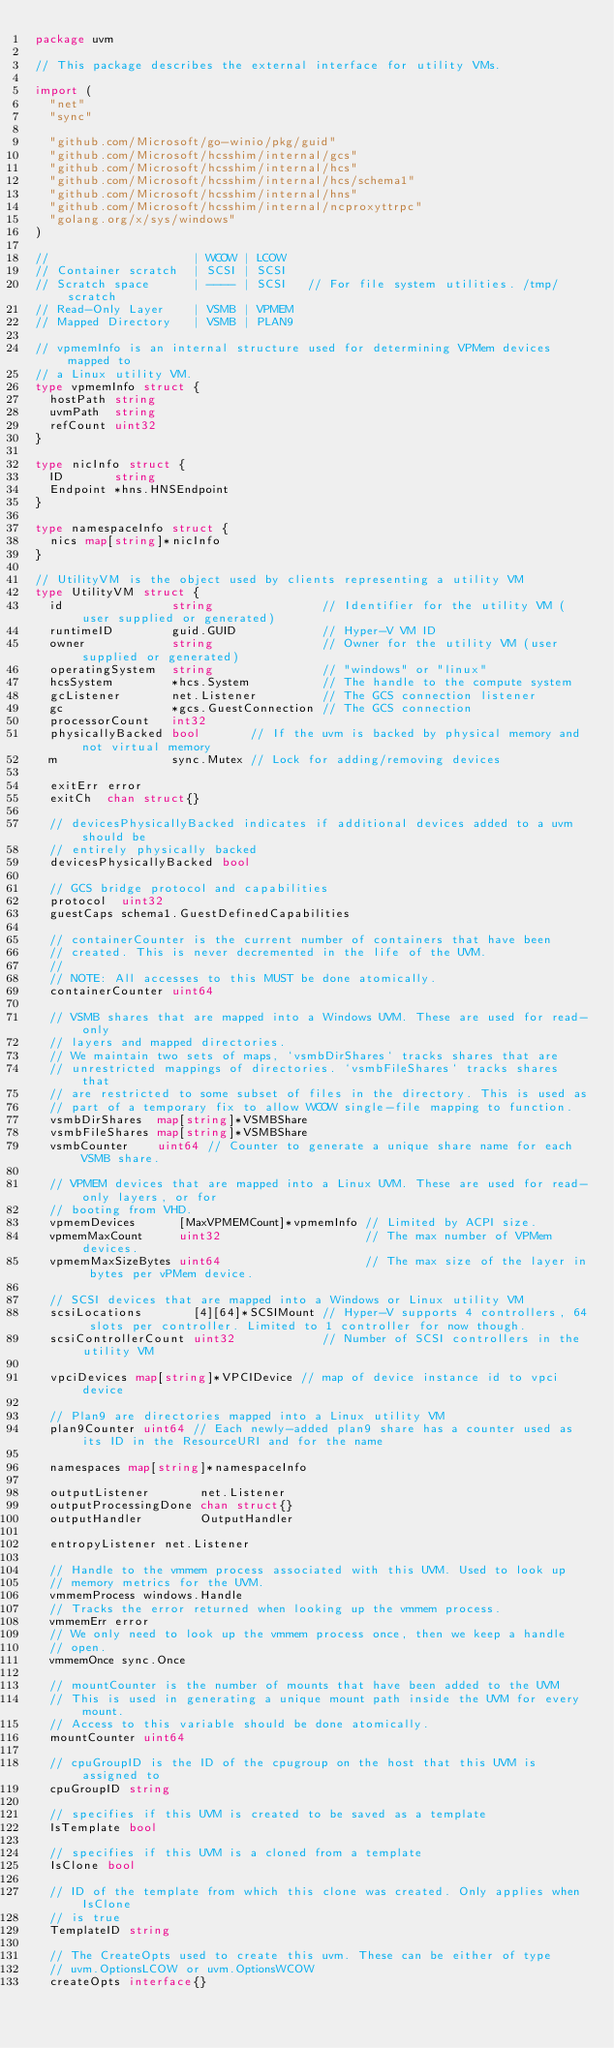Convert code to text. <code><loc_0><loc_0><loc_500><loc_500><_Go_>package uvm

// This package describes the external interface for utility VMs.

import (
	"net"
	"sync"

	"github.com/Microsoft/go-winio/pkg/guid"
	"github.com/Microsoft/hcsshim/internal/gcs"
	"github.com/Microsoft/hcsshim/internal/hcs"
	"github.com/Microsoft/hcsshim/internal/hcs/schema1"
	"github.com/Microsoft/hcsshim/internal/hns"
	"github.com/Microsoft/hcsshim/internal/ncproxyttrpc"
	"golang.org/x/sys/windows"
)

//                    | WCOW | LCOW
// Container scratch  | SCSI | SCSI
// Scratch space      | ---- | SCSI   // For file system utilities. /tmp/scratch
// Read-Only Layer    | VSMB | VPMEM
// Mapped Directory   | VSMB | PLAN9

// vpmemInfo is an internal structure used for determining VPMem devices mapped to
// a Linux utility VM.
type vpmemInfo struct {
	hostPath string
	uvmPath  string
	refCount uint32
}

type nicInfo struct {
	ID       string
	Endpoint *hns.HNSEndpoint
}

type namespaceInfo struct {
	nics map[string]*nicInfo
}

// UtilityVM is the object used by clients representing a utility VM
type UtilityVM struct {
	id               string               // Identifier for the utility VM (user supplied or generated)
	runtimeID        guid.GUID            // Hyper-V VM ID
	owner            string               // Owner for the utility VM (user supplied or generated)
	operatingSystem  string               // "windows" or "linux"
	hcsSystem        *hcs.System          // The handle to the compute system
	gcListener       net.Listener         // The GCS connection listener
	gc               *gcs.GuestConnection // The GCS connection
	processorCount   int32
	physicallyBacked bool       // If the uvm is backed by physical memory and not virtual memory
	m                sync.Mutex // Lock for adding/removing devices

	exitErr error
	exitCh  chan struct{}

	// devicesPhysicallyBacked indicates if additional devices added to a uvm should be
	// entirely physically backed
	devicesPhysicallyBacked bool

	// GCS bridge protocol and capabilities
	protocol  uint32
	guestCaps schema1.GuestDefinedCapabilities

	// containerCounter is the current number of containers that have been
	// created. This is never decremented in the life of the UVM.
	//
	// NOTE: All accesses to this MUST be done atomically.
	containerCounter uint64

	// VSMB shares that are mapped into a Windows UVM. These are used for read-only
	// layers and mapped directories.
	// We maintain two sets of maps, `vsmbDirShares` tracks shares that are
	// unrestricted mappings of directories. `vsmbFileShares` tracks shares that
	// are restricted to some subset of files in the directory. This is used as
	// part of a temporary fix to allow WCOW single-file mapping to function.
	vsmbDirShares  map[string]*VSMBShare
	vsmbFileShares map[string]*VSMBShare
	vsmbCounter    uint64 // Counter to generate a unique share name for each VSMB share.

	// VPMEM devices that are mapped into a Linux UVM. These are used for read-only layers, or for
	// booting from VHD.
	vpmemDevices      [MaxVPMEMCount]*vpmemInfo // Limited by ACPI size.
	vpmemMaxCount     uint32                    // The max number of VPMem devices.
	vpmemMaxSizeBytes uint64                    // The max size of the layer in bytes per vPMem device.

	// SCSI devices that are mapped into a Windows or Linux utility VM
	scsiLocations       [4][64]*SCSIMount // Hyper-V supports 4 controllers, 64 slots per controller. Limited to 1 controller for now though.
	scsiControllerCount uint32            // Number of SCSI controllers in the utility VM

	vpciDevices map[string]*VPCIDevice // map of device instance id to vpci device

	// Plan9 are directories mapped into a Linux utility VM
	plan9Counter uint64 // Each newly-added plan9 share has a counter used as its ID in the ResourceURI and for the name

	namespaces map[string]*namespaceInfo

	outputListener       net.Listener
	outputProcessingDone chan struct{}
	outputHandler        OutputHandler

	entropyListener net.Listener

	// Handle to the vmmem process associated with this UVM. Used to look up
	// memory metrics for the UVM.
	vmmemProcess windows.Handle
	// Tracks the error returned when looking up the vmmem process.
	vmmemErr error
	// We only need to look up the vmmem process once, then we keep a handle
	// open.
	vmmemOnce sync.Once

	// mountCounter is the number of mounts that have been added to the UVM
	// This is used in generating a unique mount path inside the UVM for every mount.
	// Access to this variable should be done atomically.
	mountCounter uint64

	// cpuGroupID is the ID of the cpugroup on the host that this UVM is assigned to
	cpuGroupID string

	// specifies if this UVM is created to be saved as a template
	IsTemplate bool

	// specifies if this UVM is a cloned from a template
	IsClone bool

	// ID of the template from which this clone was created. Only applies when IsClone
	// is true
	TemplateID string

	// The CreateOpts used to create this uvm. These can be either of type
	// uvm.OptionsLCOW or uvm.OptionsWCOW
	createOpts interface{}</code> 